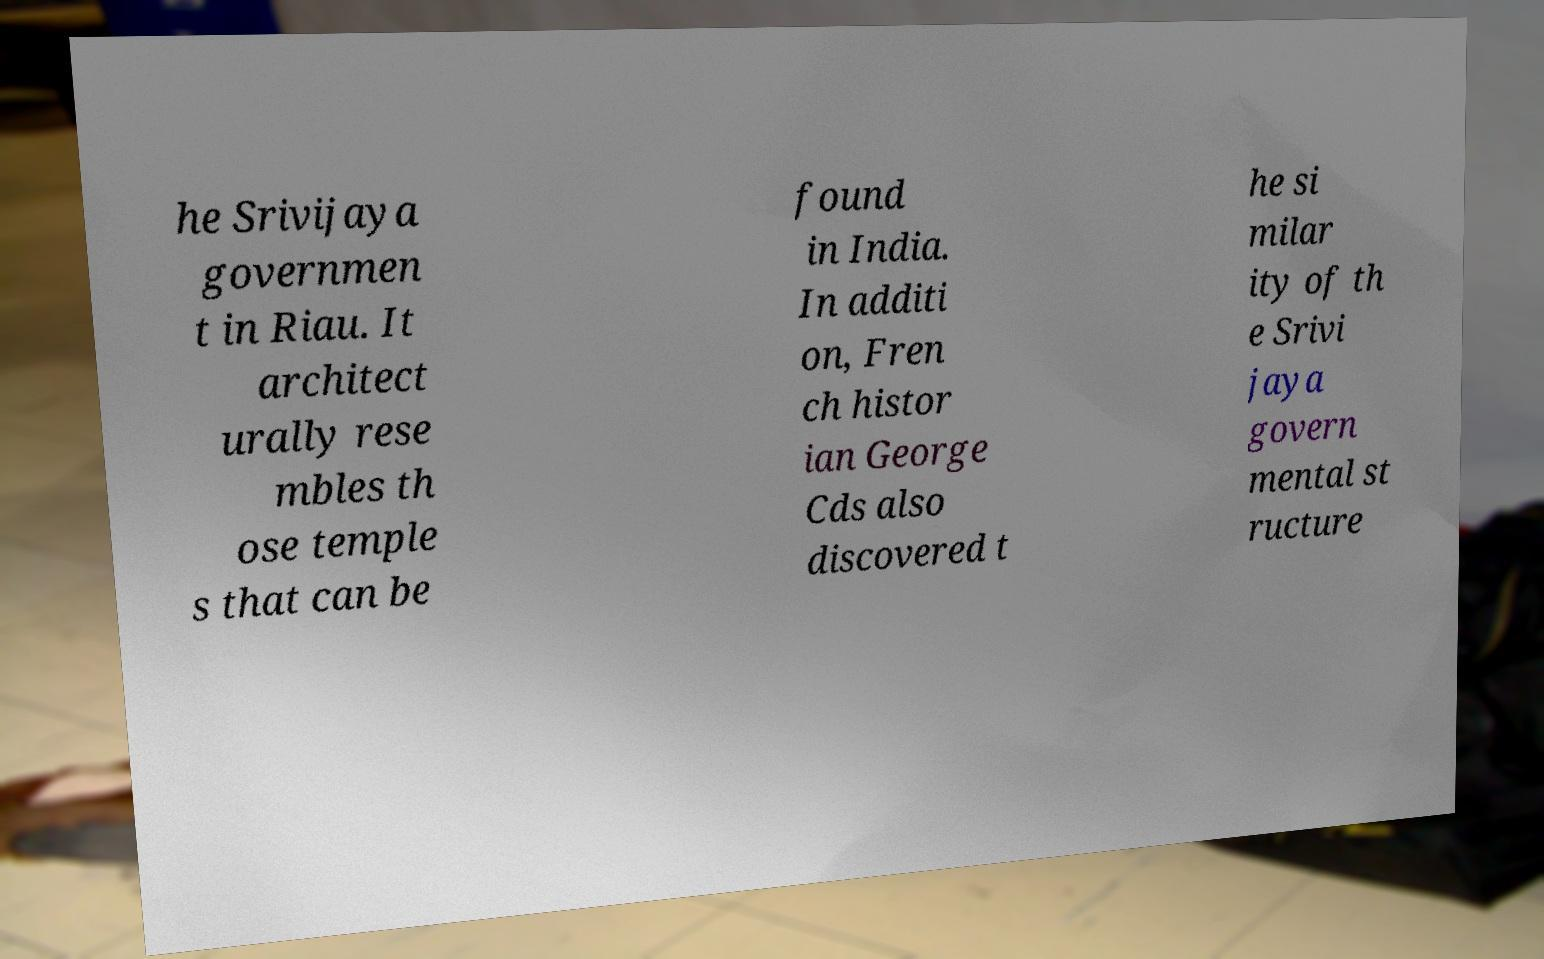Please read and relay the text visible in this image. What does it say? he Srivijaya governmen t in Riau. It architect urally rese mbles th ose temple s that can be found in India. In additi on, Fren ch histor ian George Cds also discovered t he si milar ity of th e Srivi jaya govern mental st ructure 